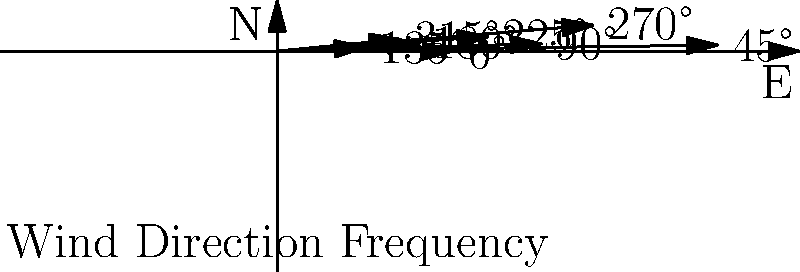As a new resident of Lake City, Minnesota, you're interested in the potential for wind energy in the area. The polar plot shows the frequency of wind directions in Lake City. Based on this data, what is the optimal angle (in degrees) for positioning wind turbines to capture the most wind energy? To determine the optimal angle for wind turbines, we need to follow these steps:

1. Analyze the wind direction frequency data:
   - The plot shows wind directions in 45° intervals.
   - The length of each arrow represents the frequency of wind from that direction.

2. Identify the dominant wind direction:
   - The longest arrow points to 45°, indicating the most frequent wind direction.

3. Consider secondary wind directions:
   - The second longest arrow points to 270° (West).
   - The third longest arrow points to 90° (East).

4. Calculate the optimal angle:
   - The optimal angle should be perpendicular to the dominant wind direction.
   - The dominant wind direction is 45°.
   - To find the perpendicular angle: $45° + 90° = 135°$

5. Verify the result:
   - An angle of 135° allows the turbine to capture wind from both the dominant 45° direction and the secondary 270° direction.

Therefore, the optimal angle for positioning wind turbines in Lake City, Minnesota, based on this data, is 135°.
Answer: 135° 